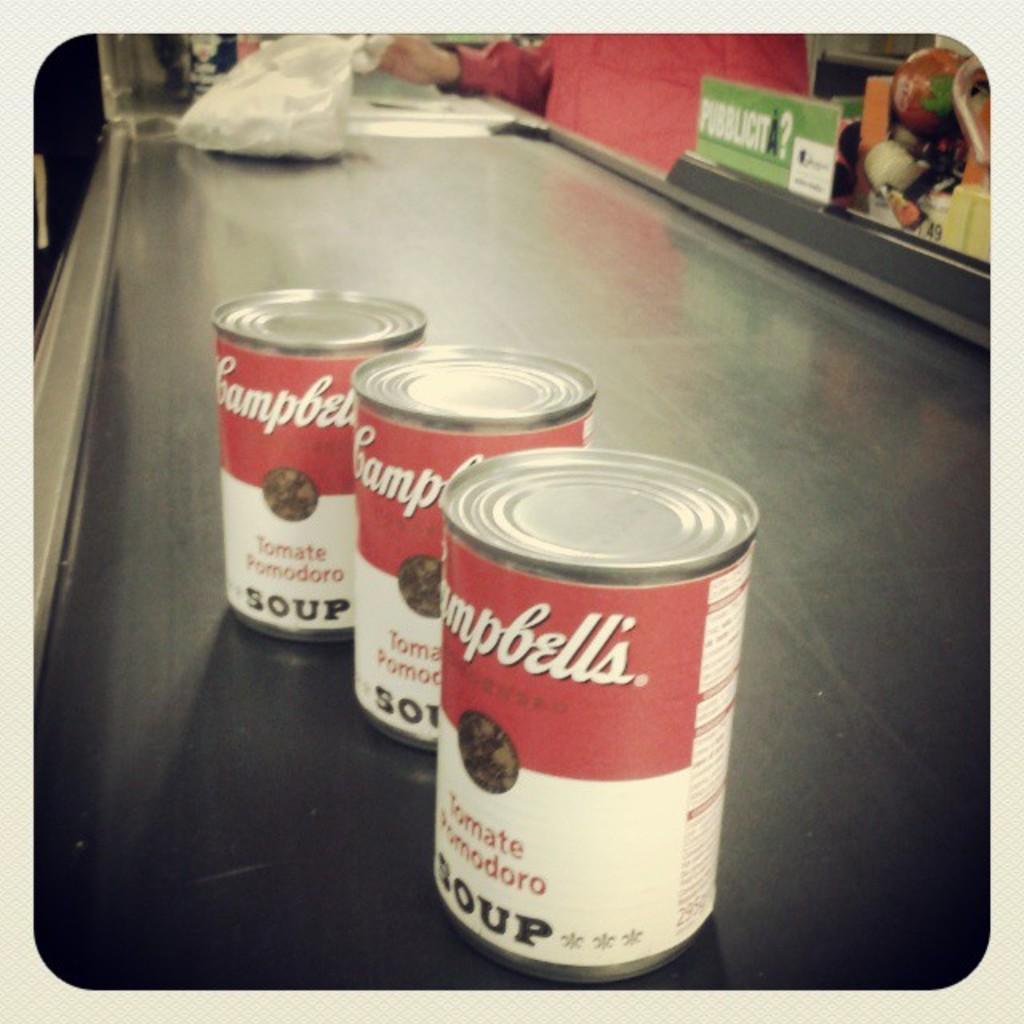Could you give a brief overview of what you see in this image? In this image we can see tins and a plastic bag on the table, there we can see a person's hand. 